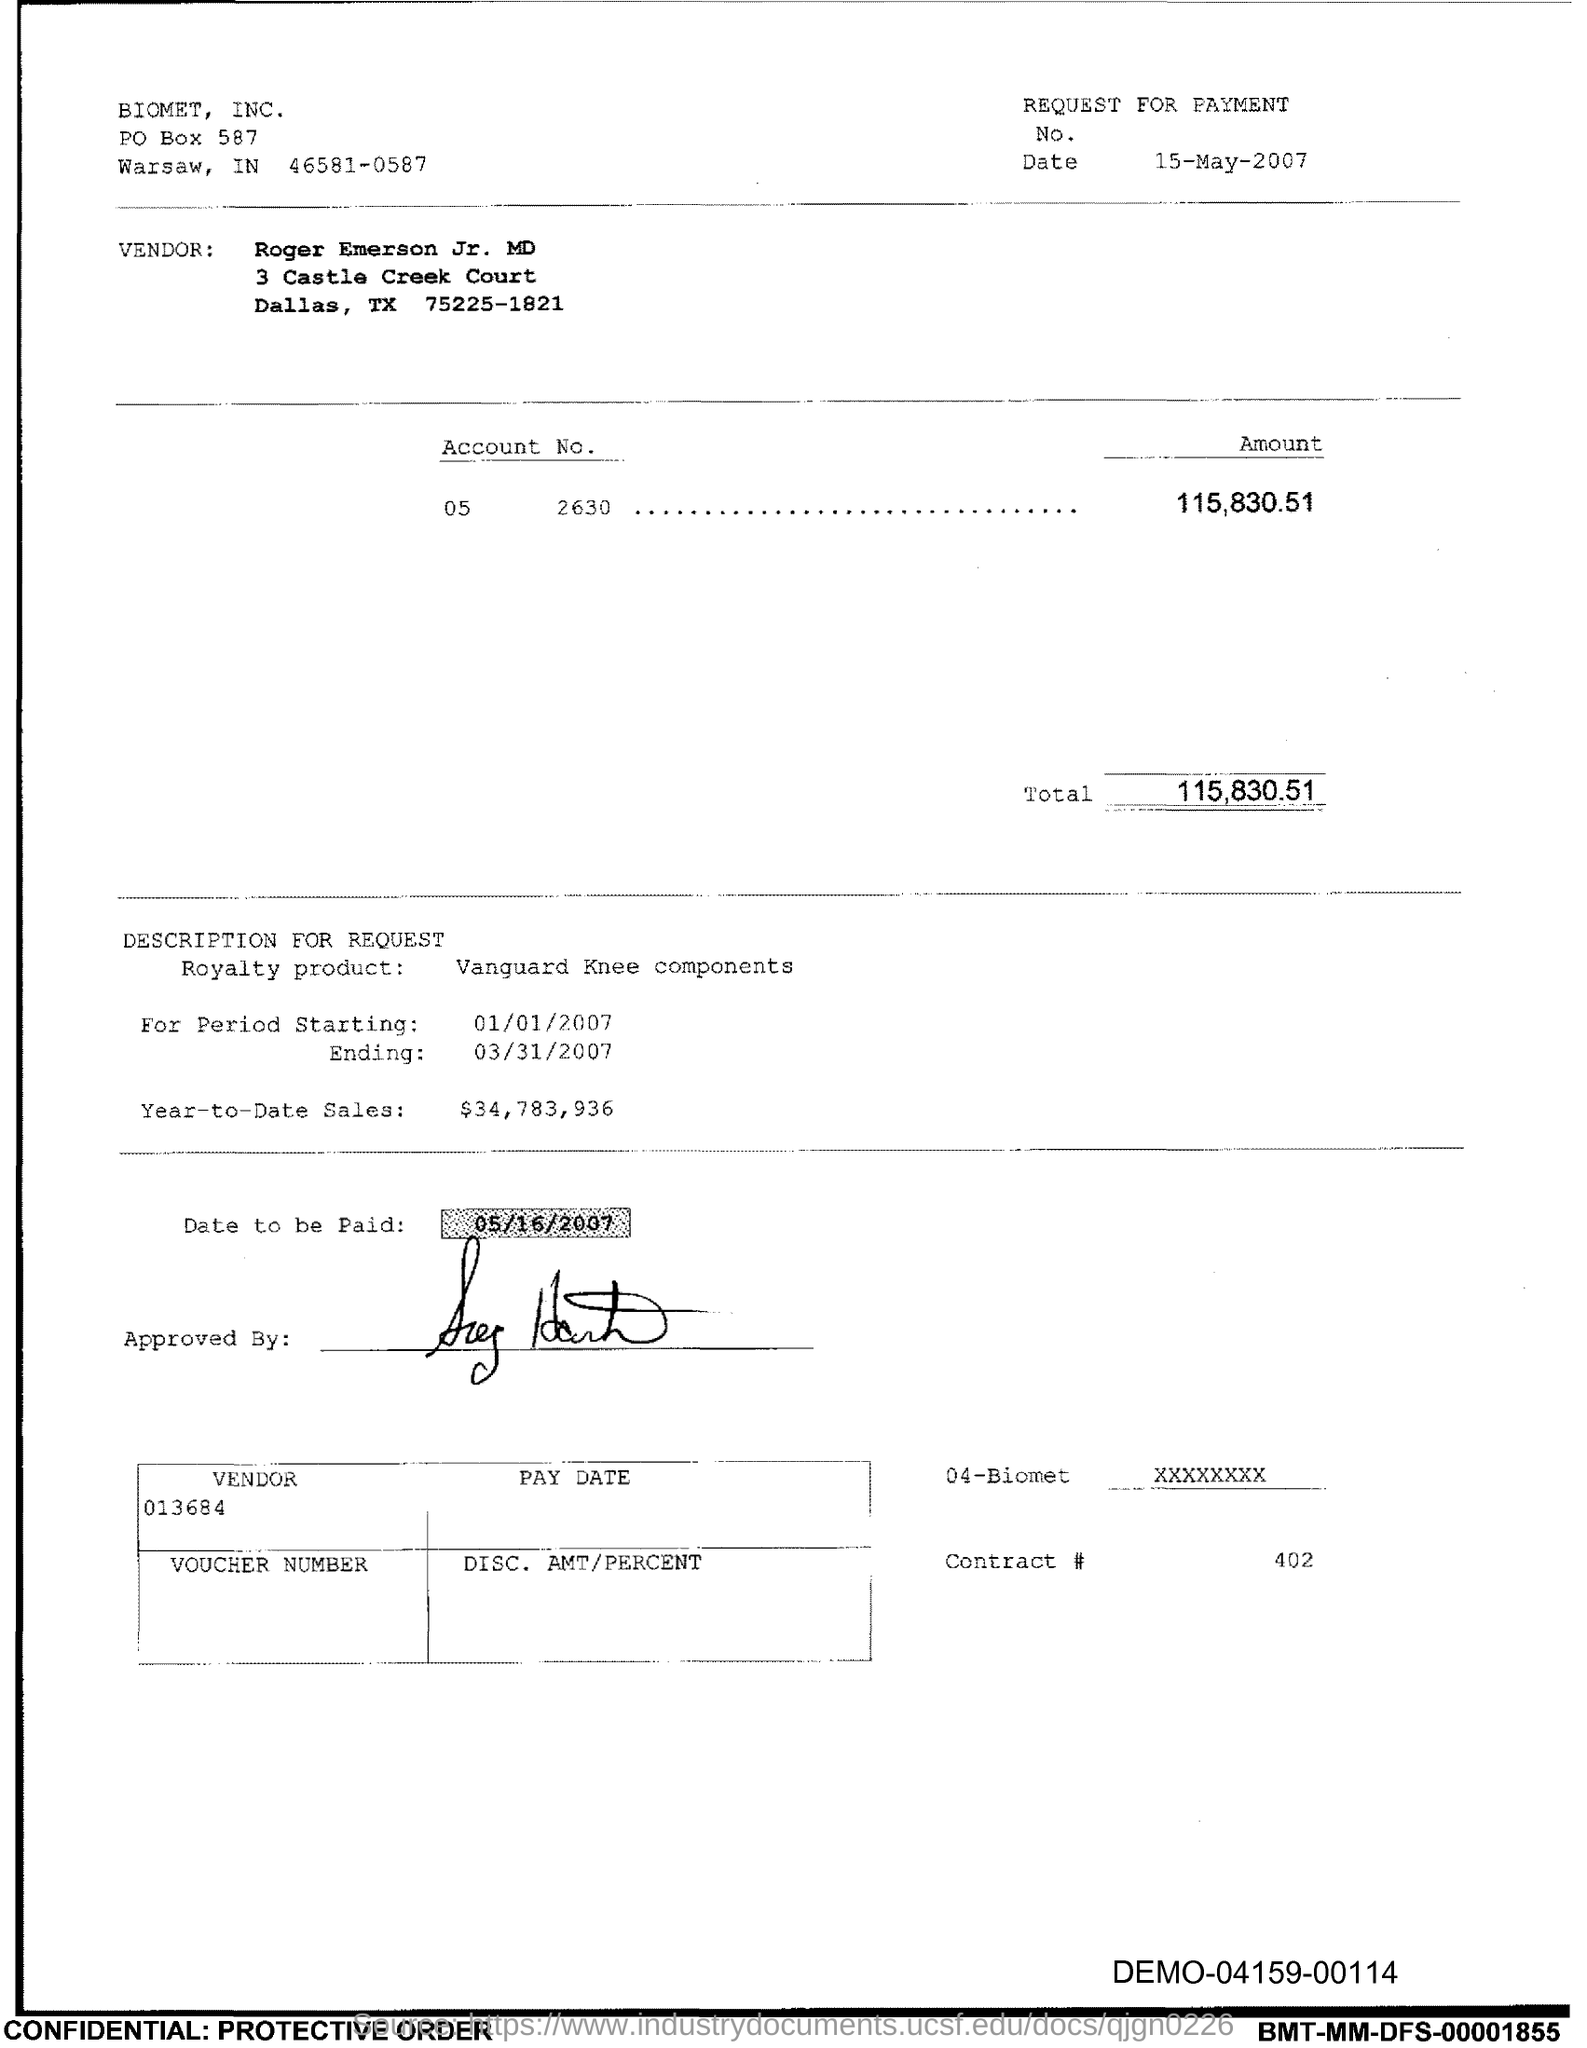Point out several critical features in this image. The account number provided in the document is 05 2630... The vendor in the document is Roger Emerson Jr., MD. Biomet, Inc. is mentioned in the header of the document. The date on which the payment is to be made, as mentioned in the document, is 05/16/2007. The royalty product, as per the document, is the Vanguard Knee Components. 